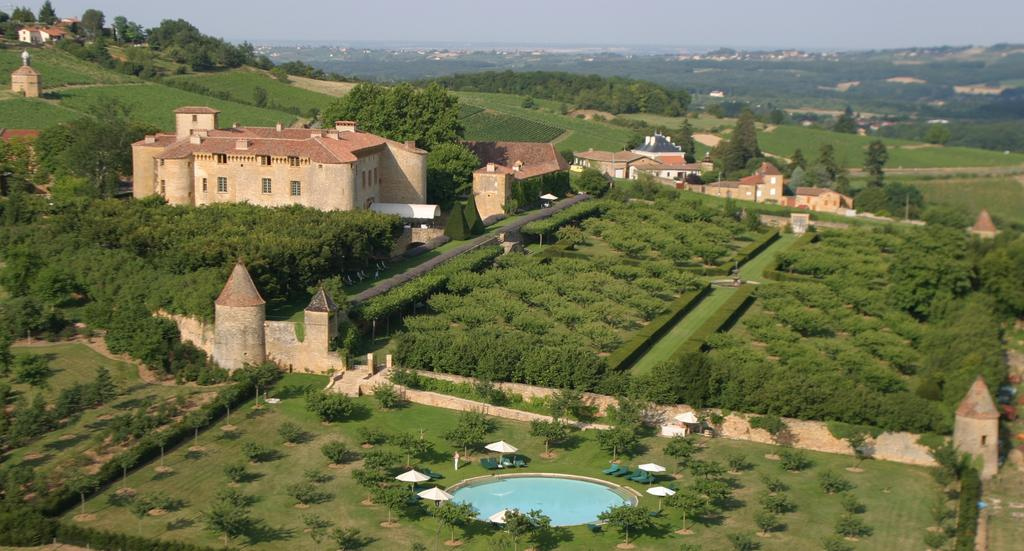What type of vegetation can be seen in the image? There are trees and grass in the image. What type of structures are present in the image? There are buildings in the image. What recreational feature can be seen in the image? There is a swimming pool in the image. What objects are present for providing shade? There are umbrellas in the image. What type of seating is available in the image? There are benches in the image. What is visible at the top of the image? The sky is visible at the top of the image. What type of line can be seen connecting the trees in the image? There is no line connecting the trees in the image. How many roses are present in the image? There are no roses present in the image. 